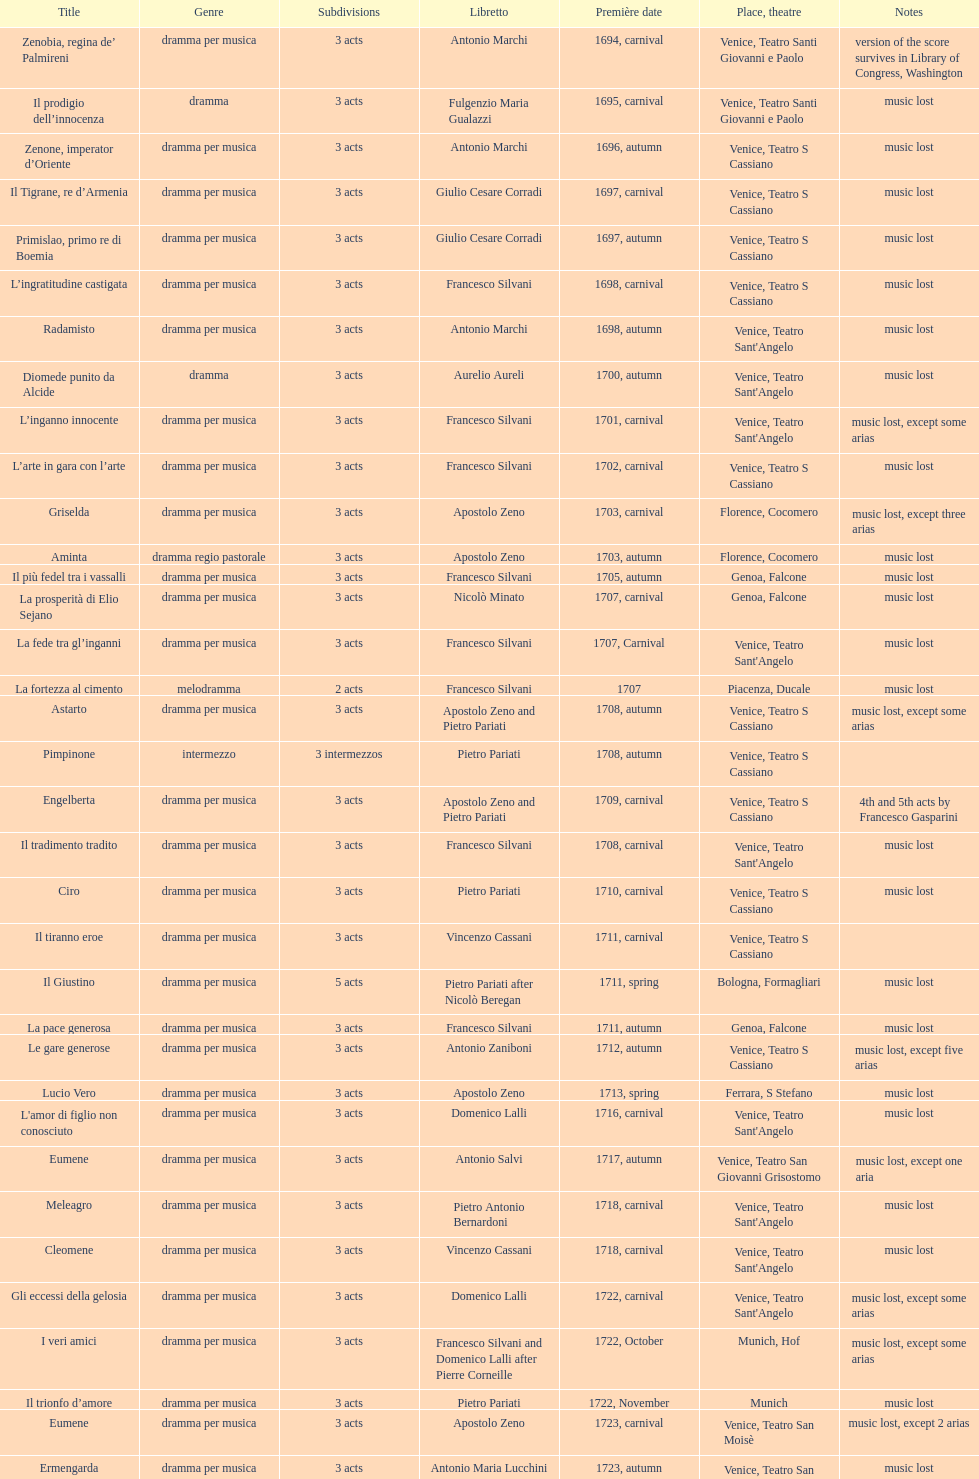I'm looking to parse the entire table for insights. Could you assist me with that? {'header': ['Title', 'Genre', 'Sub\xaddivisions', 'Libretto', 'Première date', 'Place, theatre', 'Notes'], 'rows': [['Zenobia, regina de’ Palmireni', 'dramma per musica', '3 acts', 'Antonio Marchi', '1694, carnival', 'Venice, Teatro Santi Giovanni e Paolo', 'version of the score survives in Library of Congress, Washington'], ['Il prodigio dell’innocenza', 'dramma', '3 acts', 'Fulgenzio Maria Gualazzi', '1695, carnival', 'Venice, Teatro Santi Giovanni e Paolo', 'music lost'], ['Zenone, imperator d’Oriente', 'dramma per musica', '3 acts', 'Antonio Marchi', '1696, autumn', 'Venice, Teatro S Cassiano', 'music lost'], ['Il Tigrane, re d’Armenia', 'dramma per musica', '3 acts', 'Giulio Cesare Corradi', '1697, carnival', 'Venice, Teatro S Cassiano', 'music lost'], ['Primislao, primo re di Boemia', 'dramma per musica', '3 acts', 'Giulio Cesare Corradi', '1697, autumn', 'Venice, Teatro S Cassiano', 'music lost'], ['L’ingratitudine castigata', 'dramma per musica', '3 acts', 'Francesco Silvani', '1698, carnival', 'Venice, Teatro S Cassiano', 'music lost'], ['Radamisto', 'dramma per musica', '3 acts', 'Antonio Marchi', '1698, autumn', "Venice, Teatro Sant'Angelo", 'music lost'], ['Diomede punito da Alcide', 'dramma', '3 acts', 'Aurelio Aureli', '1700, autumn', "Venice, Teatro Sant'Angelo", 'music lost'], ['L’inganno innocente', 'dramma per musica', '3 acts', 'Francesco Silvani', '1701, carnival', "Venice, Teatro Sant'Angelo", 'music lost, except some arias'], ['L’arte in gara con l’arte', 'dramma per musica', '3 acts', 'Francesco Silvani', '1702, carnival', 'Venice, Teatro S Cassiano', 'music lost'], ['Griselda', 'dramma per musica', '3 acts', 'Apostolo Zeno', '1703, carnival', 'Florence, Cocomero', 'music lost, except three arias'], ['Aminta', 'dramma regio pastorale', '3 acts', 'Apostolo Zeno', '1703, autumn', 'Florence, Cocomero', 'music lost'], ['Il più fedel tra i vassalli', 'dramma per musica', '3 acts', 'Francesco Silvani', '1705, autumn', 'Genoa, Falcone', 'music lost'], ['La prosperità di Elio Sejano', 'dramma per musica', '3 acts', 'Nicolò Minato', '1707, carnival', 'Genoa, Falcone', 'music lost'], ['La fede tra gl’inganni', 'dramma per musica', '3 acts', 'Francesco Silvani', '1707, Carnival', "Venice, Teatro Sant'Angelo", 'music lost'], ['La fortezza al cimento', 'melodramma', '2 acts', 'Francesco Silvani', '1707', 'Piacenza, Ducale', 'music lost'], ['Astarto', 'dramma per musica', '3 acts', 'Apostolo Zeno and Pietro Pariati', '1708, autumn', 'Venice, Teatro S Cassiano', 'music lost, except some arias'], ['Pimpinone', 'intermezzo', '3 intermezzos', 'Pietro Pariati', '1708, autumn', 'Venice, Teatro S Cassiano', ''], ['Engelberta', 'dramma per musica', '3 acts', 'Apostolo Zeno and Pietro Pariati', '1709, carnival', 'Venice, Teatro S Cassiano', '4th and 5th acts by Francesco Gasparini'], ['Il tradimento tradito', 'dramma per musica', '3 acts', 'Francesco Silvani', '1708, carnival', "Venice, Teatro Sant'Angelo", 'music lost'], ['Ciro', 'dramma per musica', '3 acts', 'Pietro Pariati', '1710, carnival', 'Venice, Teatro S Cassiano', 'music lost'], ['Il tiranno eroe', 'dramma per musica', '3 acts', 'Vincenzo Cassani', '1711, carnival', 'Venice, Teatro S Cassiano', ''], ['Il Giustino', 'dramma per musica', '5 acts', 'Pietro Pariati after Nicolò Beregan', '1711, spring', 'Bologna, Formagliari', 'music lost'], ['La pace generosa', 'dramma per musica', '3 acts', 'Francesco Silvani', '1711, autumn', 'Genoa, Falcone', 'music lost'], ['Le gare generose', 'dramma per musica', '3 acts', 'Antonio Zaniboni', '1712, autumn', 'Venice, Teatro S Cassiano', 'music lost, except five arias'], ['Lucio Vero', 'dramma per musica', '3 acts', 'Apostolo Zeno', '1713, spring', 'Ferrara, S Stefano', 'music lost'], ["L'amor di figlio non conosciuto", 'dramma per musica', '3 acts', 'Domenico Lalli', '1716, carnival', "Venice, Teatro Sant'Angelo", 'music lost'], ['Eumene', 'dramma per musica', '3 acts', 'Antonio Salvi', '1717, autumn', 'Venice, Teatro San Giovanni Grisostomo', 'music lost, except one aria'], ['Meleagro', 'dramma per musica', '3 acts', 'Pietro Antonio Bernardoni', '1718, carnival', "Venice, Teatro Sant'Angelo", 'music lost'], ['Cleomene', 'dramma per musica', '3 acts', 'Vincenzo Cassani', '1718, carnival', "Venice, Teatro Sant'Angelo", 'music lost'], ['Gli eccessi della gelosia', 'dramma per musica', '3 acts', 'Domenico Lalli', '1722, carnival', "Venice, Teatro Sant'Angelo", 'music lost, except some arias'], ['I veri amici', 'dramma per musica', '3 acts', 'Francesco Silvani and Domenico Lalli after Pierre Corneille', '1722, October', 'Munich, Hof', 'music lost, except some arias'], ['Il trionfo d’amore', 'dramma per musica', '3 acts', 'Pietro Pariati', '1722, November', 'Munich', 'music lost'], ['Eumene', 'dramma per musica', '3 acts', 'Apostolo Zeno', '1723, carnival', 'Venice, Teatro San Moisè', 'music lost, except 2 arias'], ['Ermengarda', 'dramma per musica', '3 acts', 'Antonio Maria Lucchini', '1723, autumn', 'Venice, Teatro San Moisè', 'music lost'], ['Antigono, tutore di Filippo, re di Macedonia', 'tragedia', '5 acts', 'Giovanni Piazzon', '1724, carnival', 'Venice, Teatro San Moisè', '5th act by Giovanni Porta, music lost'], ['Scipione nelle Spagne', 'dramma per musica', '3 acts', 'Apostolo Zeno', '1724, Ascension', 'Venice, Teatro San Samuele', 'music lost'], ['Laodice', 'dramma per musica', '3 acts', 'Angelo Schietti', '1724, autumn', 'Venice, Teatro San Moisè', 'music lost, except 2 arias'], ['Didone abbandonata', 'tragedia', '3 acts', 'Metastasio', '1725, carnival', 'Venice, Teatro S Cassiano', 'music lost'], ["L'impresario delle Isole Canarie", 'intermezzo', '2 acts', 'Metastasio', '1725, carnival', 'Venice, Teatro S Cassiano', 'music lost'], ['Alcina delusa da Ruggero', 'dramma per musica', '3 acts', 'Antonio Marchi', '1725, autumn', 'Venice, Teatro S Cassiano', 'music lost'], ['I rivali generosi', 'dramma per musica', '3 acts', 'Apostolo Zeno', '1725', 'Brescia, Nuovo', ''], ['La Statira', 'dramma per musica', '3 acts', 'Apostolo Zeno and Pietro Pariati', '1726, Carnival', 'Rome, Teatro Capranica', ''], ['Malsazio e Fiammetta', 'intermezzo', '', '', '1726, Carnival', 'Rome, Teatro Capranica', ''], ['Il trionfo di Armida', 'dramma per musica', '3 acts', 'Girolamo Colatelli after Torquato Tasso', '1726, autumn', 'Venice, Teatro San Moisè', 'music lost'], ['L’incostanza schernita', 'dramma comico-pastorale', '3 acts', 'Vincenzo Cassani', '1727, Ascension', 'Venice, Teatro San Samuele', 'music lost, except some arias'], ['Le due rivali in amore', 'dramma per musica', '3 acts', 'Aurelio Aureli', '1728, autumn', 'Venice, Teatro San Moisè', 'music lost'], ['Il Satrapone', 'intermezzo', '', 'Salvi', '1729', 'Parma, Omodeo', ''], ['Li stratagemmi amorosi', 'dramma per musica', '3 acts', 'F Passerini', '1730, carnival', 'Venice, Teatro San Moisè', 'music lost'], ['Elenia', 'dramma per musica', '3 acts', 'Luisa Bergalli', '1730, carnival', "Venice, Teatro Sant'Angelo", 'music lost'], ['Merope', 'dramma', '3 acts', 'Apostolo Zeno', '1731, autumn', 'Prague, Sporck Theater', 'mostly by Albinoni, music lost'], ['Il più infedel tra gli amanti', 'dramma per musica', '3 acts', 'Angelo Schietti', '1731, autumn', 'Treviso, Dolphin', 'music lost'], ['Ardelinda', 'dramma', '3 acts', 'Bartolomeo Vitturi', '1732, autumn', "Venice, Teatro Sant'Angelo", 'music lost, except five arias'], ['Candalide', 'dramma per musica', '3 acts', 'Bartolomeo Vitturi', '1734, carnival', "Venice, Teatro Sant'Angelo", 'music lost'], ['Artamene', 'dramma per musica', '3 acts', 'Bartolomeo Vitturi', '1741, carnival', "Venice, Teatro Sant'Angelo", 'music lost']]} Which opera has at least 5 acts? Il Giustino. 